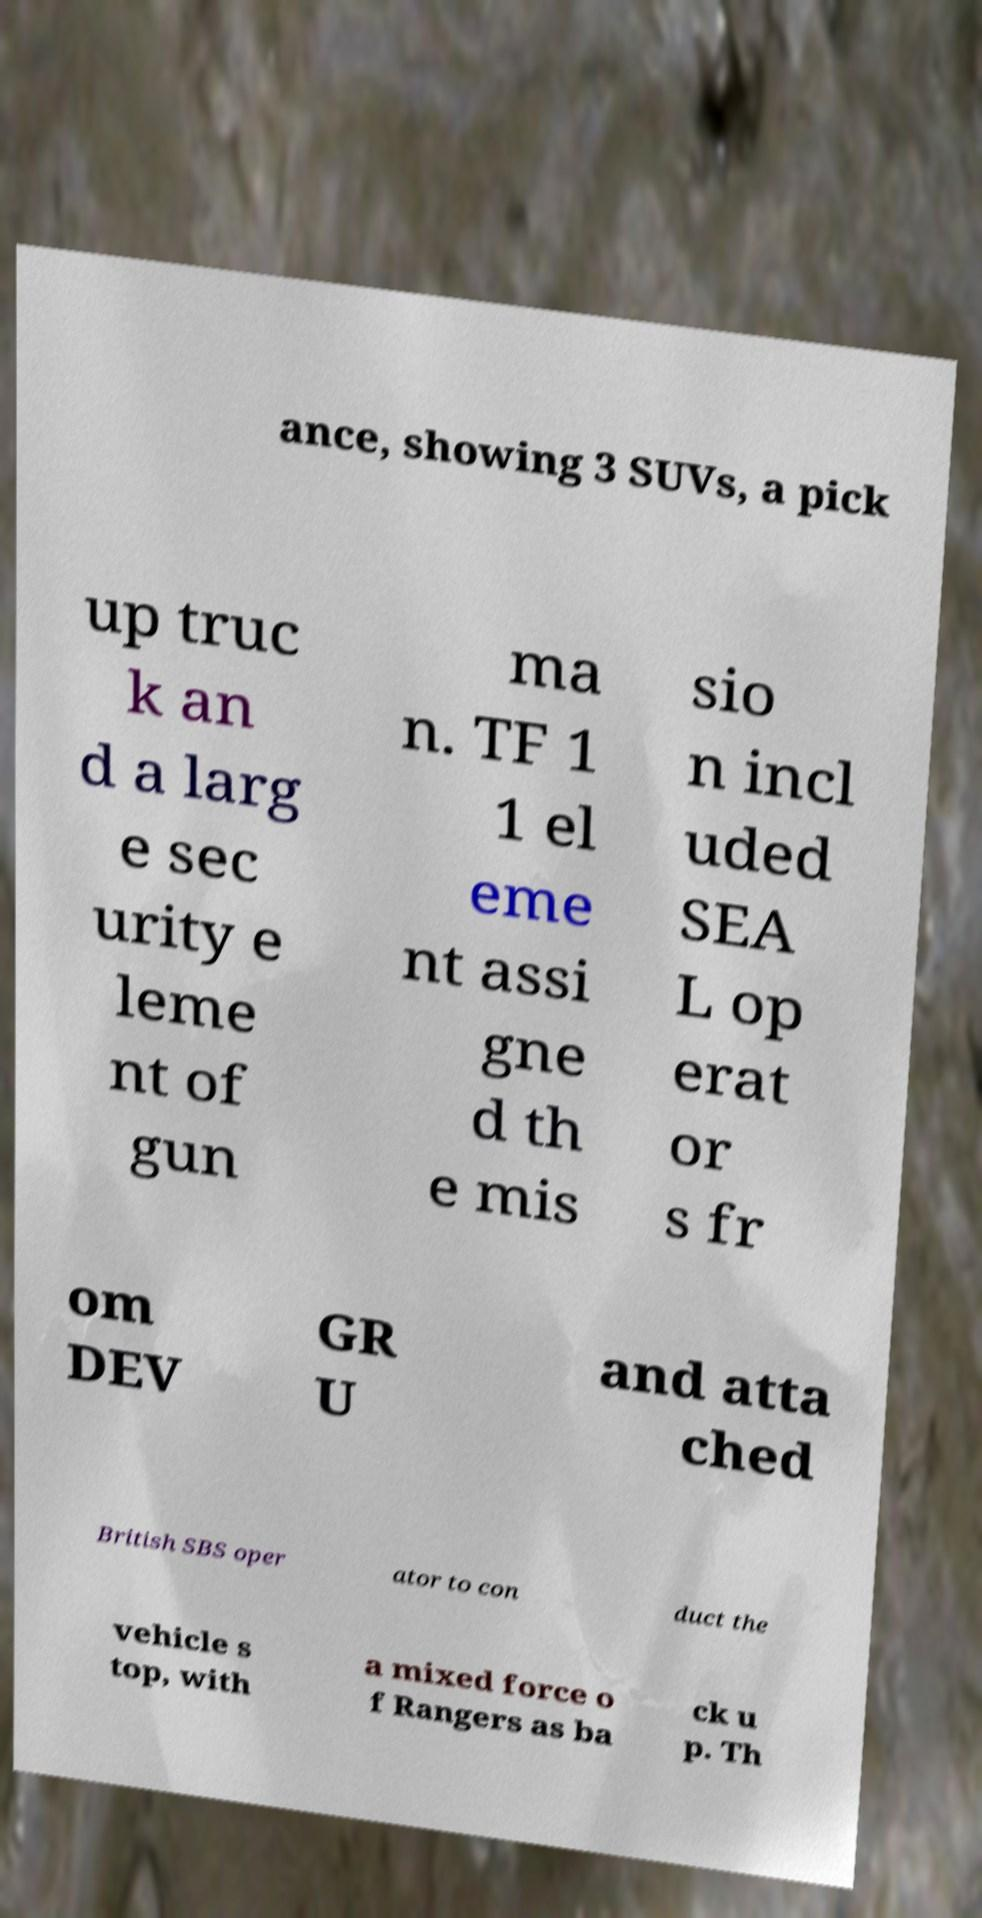What messages or text are displayed in this image? I need them in a readable, typed format. ance, showing 3 SUVs, a pick up truc k an d a larg e sec urity e leme nt of gun ma n. TF 1 1 el eme nt assi gne d th e mis sio n incl uded SEA L op erat or s fr om DEV GR U and atta ched British SBS oper ator to con duct the vehicle s top, with a mixed force o f Rangers as ba ck u p. Th 